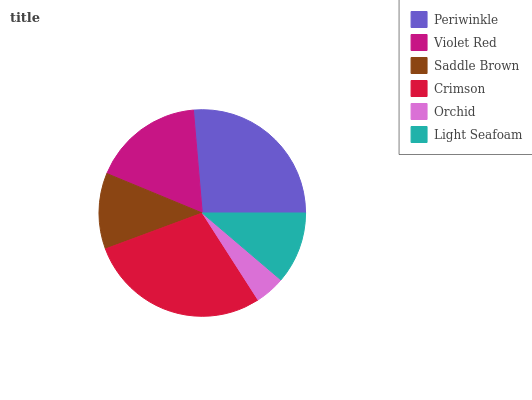Is Orchid the minimum?
Answer yes or no. Yes. Is Crimson the maximum?
Answer yes or no. Yes. Is Violet Red the minimum?
Answer yes or no. No. Is Violet Red the maximum?
Answer yes or no. No. Is Periwinkle greater than Violet Red?
Answer yes or no. Yes. Is Violet Red less than Periwinkle?
Answer yes or no. Yes. Is Violet Red greater than Periwinkle?
Answer yes or no. No. Is Periwinkle less than Violet Red?
Answer yes or no. No. Is Violet Red the high median?
Answer yes or no. Yes. Is Saddle Brown the low median?
Answer yes or no. Yes. Is Crimson the high median?
Answer yes or no. No. Is Periwinkle the low median?
Answer yes or no. No. 